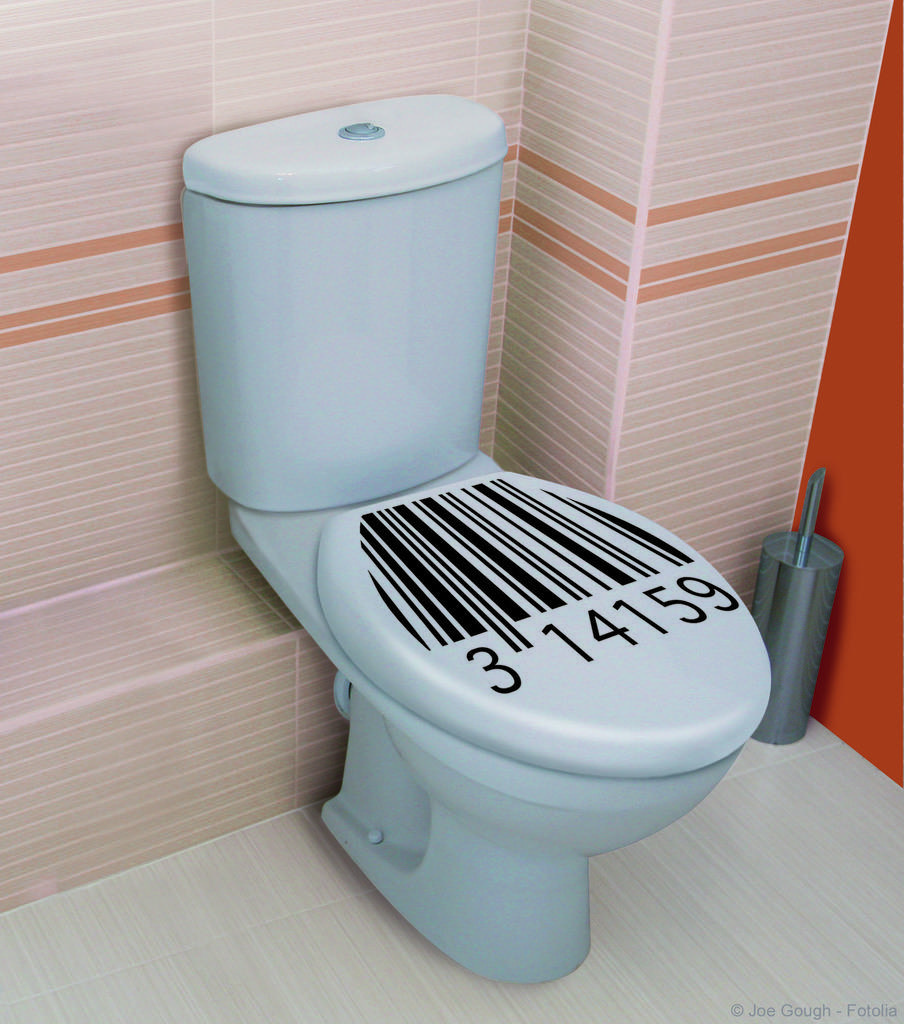What numbers are on the toilet lid?
Your response must be concise. 314159. 